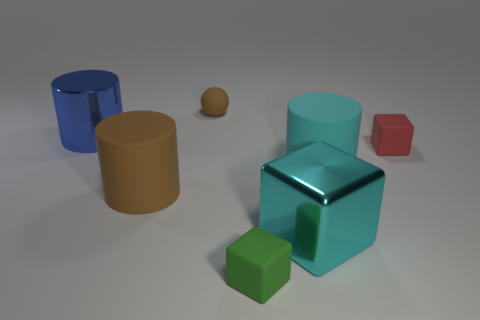There is a rubber cylinder that is to the left of the brown rubber thing that is behind the shiny object that is on the left side of the green rubber thing; what is its size?
Your answer should be compact. Large. There is a large thing that is to the right of the big cyan shiny thing; is its color the same as the large shiny block?
Provide a short and direct response. Yes. What is the size of the red rubber thing that is the same shape as the large cyan metallic object?
Your answer should be compact. Small. What number of objects are either tiny things that are left of the green cube or small rubber objects behind the large shiny cylinder?
Offer a terse response. 1. The small matte object behind the tiny rubber block right of the small green cube is what shape?
Offer a very short reply. Sphere. Is there any other thing of the same color as the metal cylinder?
Make the answer very short. No. Is there any other thing that is the same size as the cyan matte cylinder?
Provide a succinct answer. Yes. How many objects are brown rubber objects or tiny yellow rubber things?
Provide a succinct answer. 2. Are there any other matte cubes that have the same size as the cyan cube?
Give a very brief answer. No. What shape is the big cyan rubber object?
Provide a succinct answer. Cylinder. 